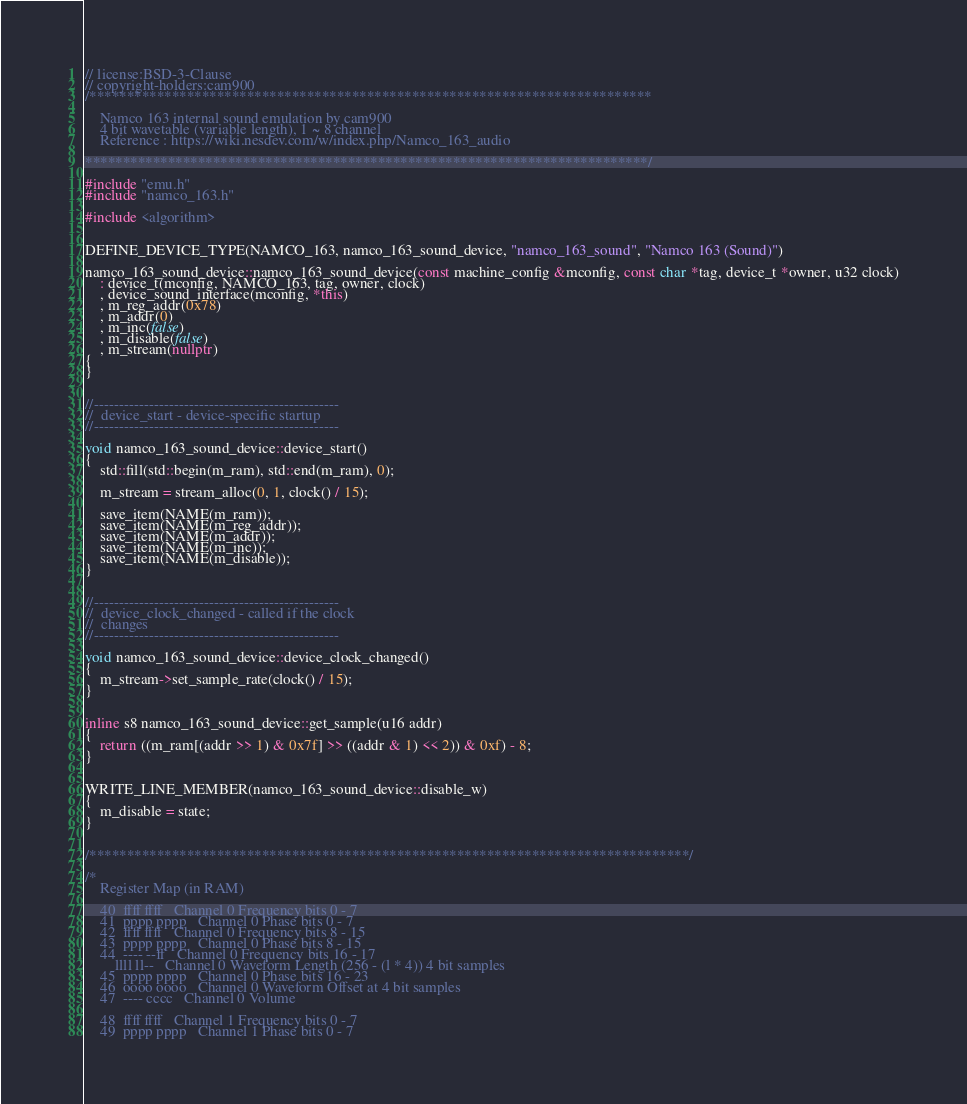Convert code to text. <code><loc_0><loc_0><loc_500><loc_500><_C++_>// license:BSD-3-Clause
// copyright-holders:cam900
/***************************************************************************

    Namco 163 internal sound emulation by cam900
    4 bit wavetable (variable length), 1 ~ 8 channel
    Reference : https://wiki.nesdev.com/w/index.php/Namco_163_audio

***************************************************************************/

#include "emu.h"
#include "namco_163.h"

#include <algorithm>


DEFINE_DEVICE_TYPE(NAMCO_163, namco_163_sound_device, "namco_163_sound", "Namco 163 (Sound)")

namco_163_sound_device::namco_163_sound_device(const machine_config &mconfig, const char *tag, device_t *owner, u32 clock)
	: device_t(mconfig, NAMCO_163, tag, owner, clock)
	, device_sound_interface(mconfig, *this)
	, m_reg_addr(0x78)
	, m_addr(0)
	, m_inc(false)
	, m_disable(false)
	, m_stream(nullptr)
{
}


//-------------------------------------------------
//  device_start - device-specific startup
//-------------------------------------------------

void namco_163_sound_device::device_start()
{
	std::fill(std::begin(m_ram), std::end(m_ram), 0);

	m_stream = stream_alloc(0, 1, clock() / 15);

	save_item(NAME(m_ram));
	save_item(NAME(m_reg_addr));
	save_item(NAME(m_addr));
	save_item(NAME(m_inc));
	save_item(NAME(m_disable));
}


//-------------------------------------------------
//  device_clock_changed - called if the clock
//  changes
//-------------------------------------------------

void namco_163_sound_device::device_clock_changed()
{
	m_stream->set_sample_rate(clock() / 15);
}


inline s8 namco_163_sound_device::get_sample(u16 addr)
{
	return ((m_ram[(addr >> 1) & 0x7f] >> ((addr & 1) << 2)) & 0xf) - 8;
}


WRITE_LINE_MEMBER(namco_163_sound_device::disable_w)
{
	m_disable = state;
}


/********************************************************************************/

/*
    Register Map (in RAM)

    40  ffff ffff   Channel 0 Frequency bits 0 - 7
    41  pppp pppp   Channel 0 Phase bits 0 - 7
    42  ffff ffff   Channel 0 Frequency bits 8 - 15
    43  pppp pppp   Channel 0 Phase bits 8 - 15
    44  ---- --ff   Channel 0 Frequency bits 16 - 17
        llll ll--   Channel 0 Waveform Length (256 - (l * 4)) 4 bit samples
    45  pppp pppp   Channel 0 Phase bits 16 - 23
    46  oooo oooo   Channel 0 Waveform Offset at 4 bit samples
    47  ---- cccc   Channel 0 Volume

    48  ffff ffff   Channel 1 Frequency bits 0 - 7
    49  pppp pppp   Channel 1 Phase bits 0 - 7</code> 